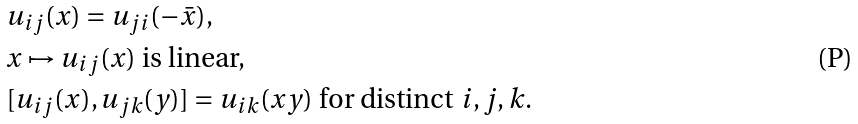Convert formula to latex. <formula><loc_0><loc_0><loc_500><loc_500>& u _ { i j } ( x ) = u _ { j i } ( - \bar { x } ) , \\ & x \mapsto u _ { i j } ( x ) \ \text {is linear,} \\ & [ u _ { i j } ( x ) , u _ { j k } ( y ) ] = u _ { i k } ( x y ) \ \text {for distinct $i,j,k$.}</formula> 